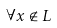Convert formula to latex. <formula><loc_0><loc_0><loc_500><loc_500>\forall x \notin L</formula> 